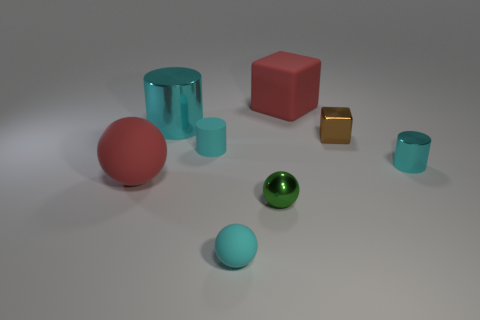Subtract all cyan shiny cylinders. How many cylinders are left? 1 Subtract all spheres. How many objects are left? 5 Subtract 2 cubes. How many cubes are left? 0 Add 2 large cyan matte objects. How many objects exist? 10 Subtract all green spheres. How many spheres are left? 2 Subtract 0 blue blocks. How many objects are left? 8 Subtract all purple balls. Subtract all gray blocks. How many balls are left? 3 Subtract all yellow blocks. How many red balls are left? 1 Subtract all big metal spheres. Subtract all small metal objects. How many objects are left? 5 Add 7 spheres. How many spheres are left? 10 